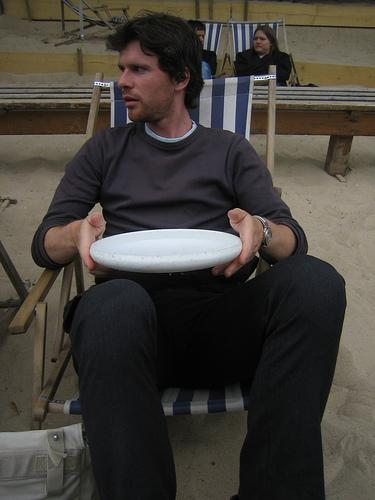What outdoor activity has the man taken a break from? frisbee 